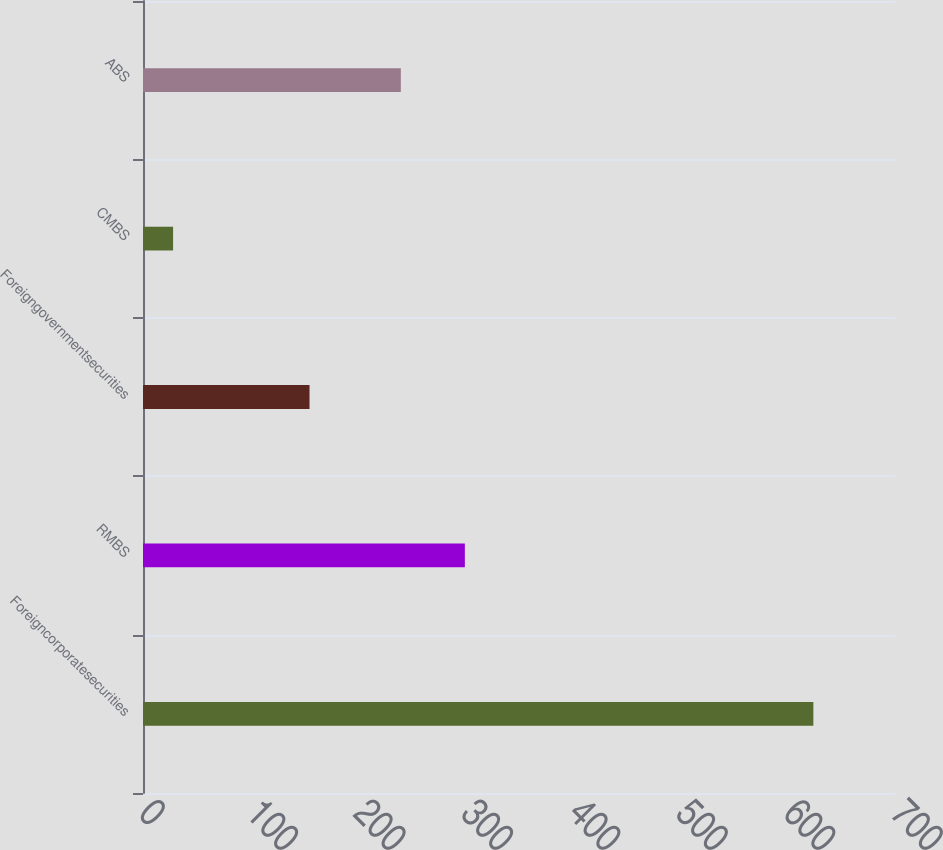Convert chart. <chart><loc_0><loc_0><loc_500><loc_500><bar_chart><fcel>Foreigncorporatesecurities<fcel>RMBS<fcel>Foreigngovernmentsecurities<fcel>CMBS<fcel>ABS<nl><fcel>624<fcel>299.6<fcel>155<fcel>28<fcel>240<nl></chart> 